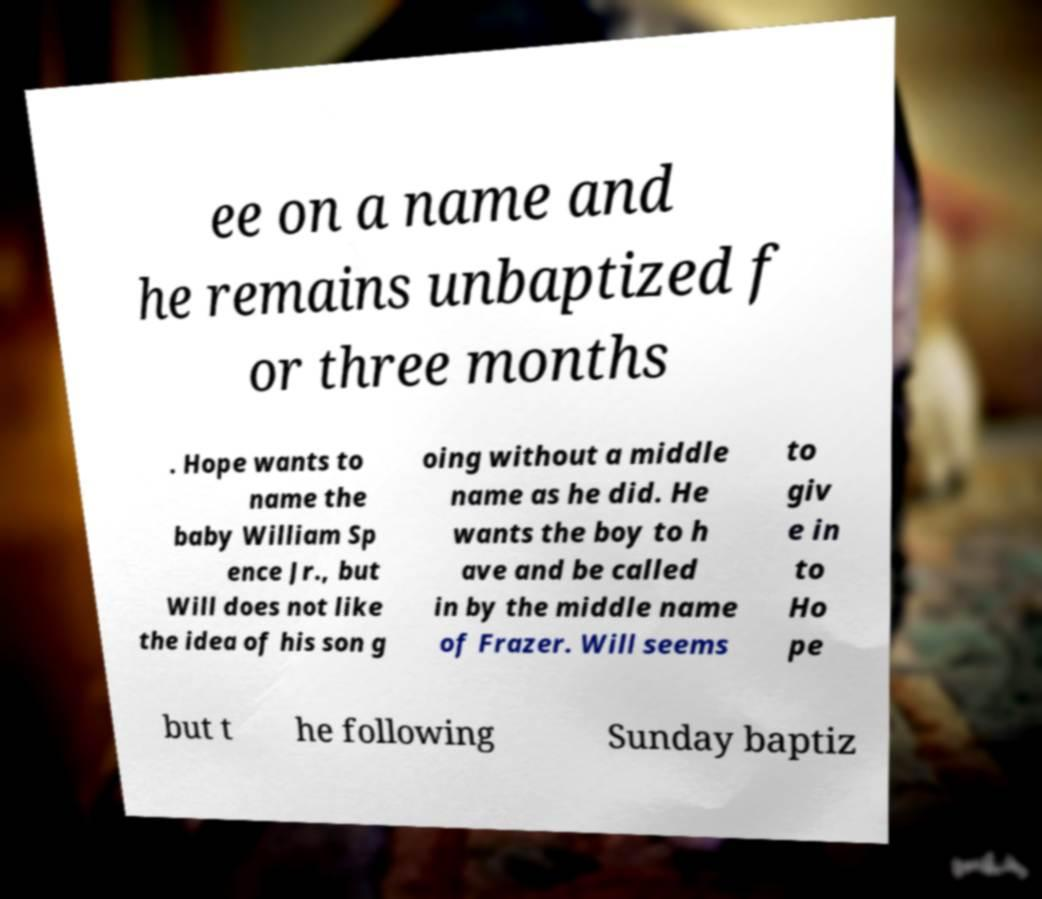I need the written content from this picture converted into text. Can you do that? ee on a name and he remains unbaptized f or three months . Hope wants to name the baby William Sp ence Jr., but Will does not like the idea of his son g oing without a middle name as he did. He wants the boy to h ave and be called in by the middle name of Frazer. Will seems to giv e in to Ho pe but t he following Sunday baptiz 